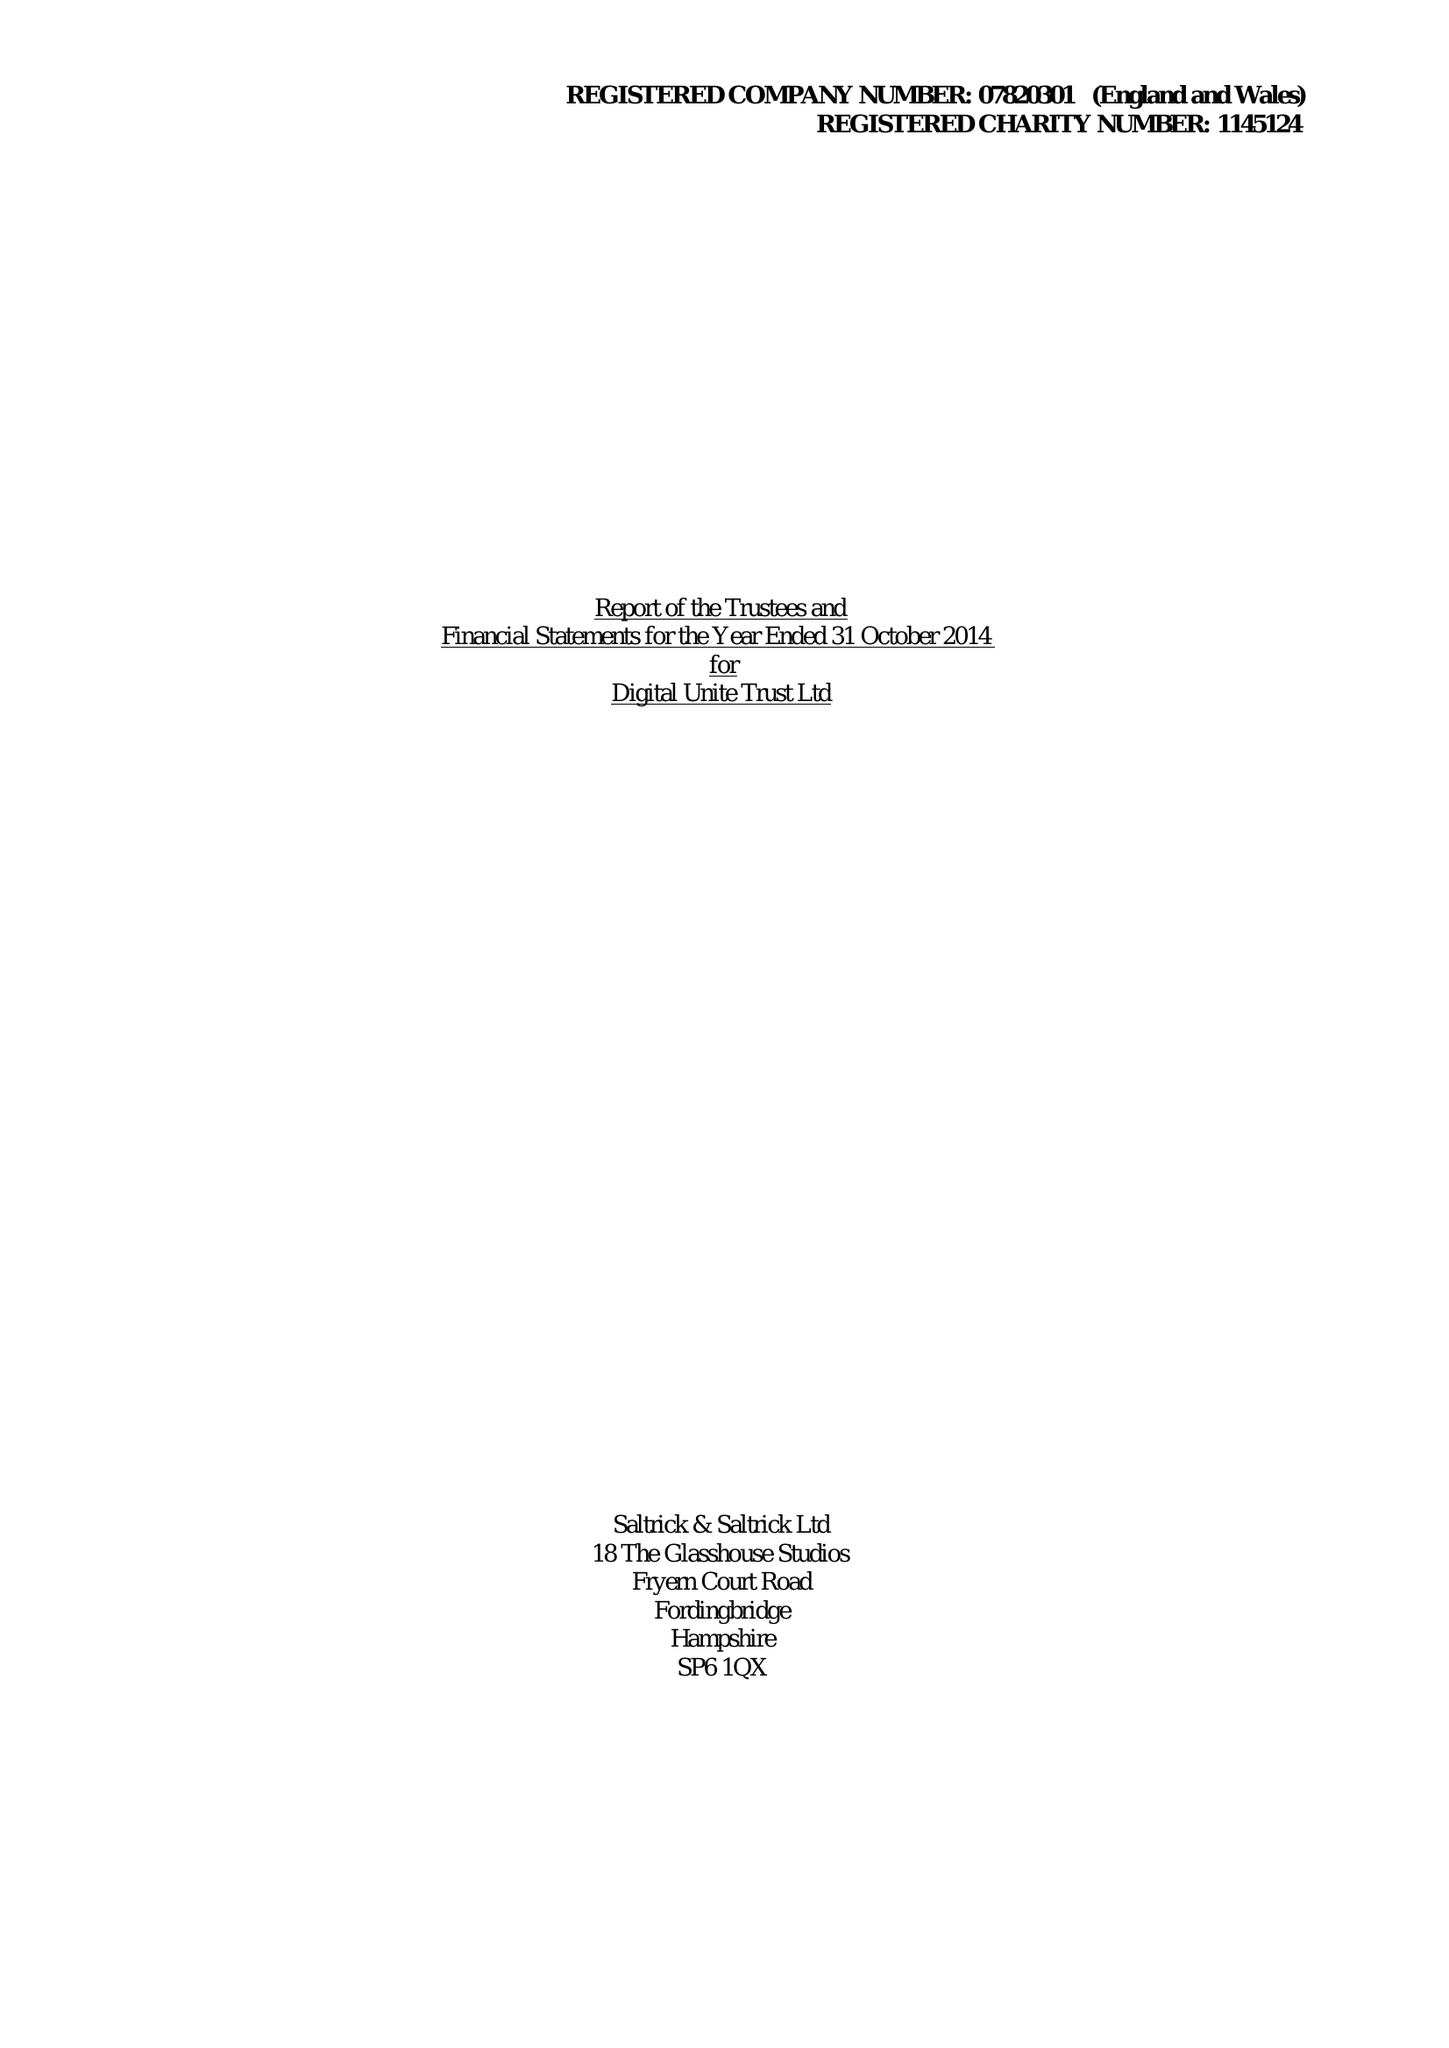What is the value for the income_annually_in_british_pounds?
Answer the question using a single word or phrase. 82925.00 